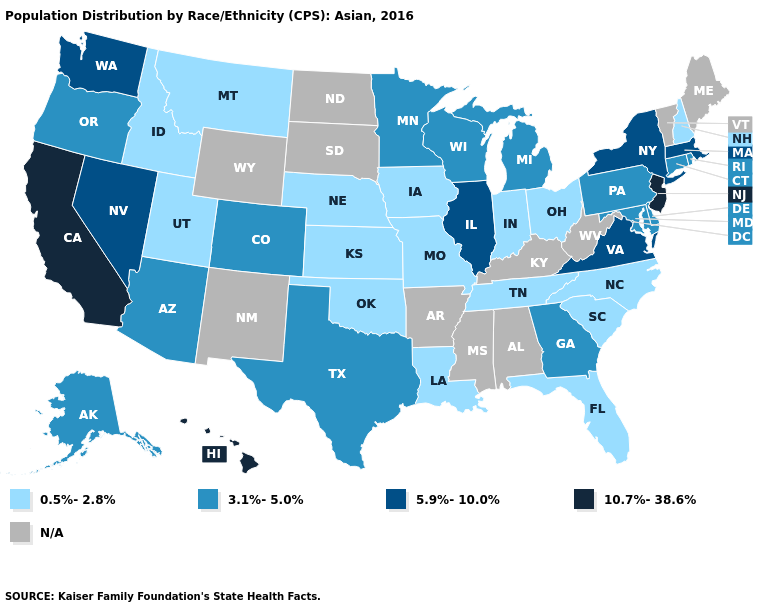What is the highest value in the USA?
Answer briefly. 10.7%-38.6%. What is the value of Nevada?
Concise answer only. 5.9%-10.0%. Which states have the lowest value in the USA?
Quick response, please. Florida, Idaho, Indiana, Iowa, Kansas, Louisiana, Missouri, Montana, Nebraska, New Hampshire, North Carolina, Ohio, Oklahoma, South Carolina, Tennessee, Utah. What is the lowest value in the MidWest?
Write a very short answer. 0.5%-2.8%. What is the value of Missouri?
Answer briefly. 0.5%-2.8%. How many symbols are there in the legend?
Quick response, please. 5. What is the value of Nebraska?
Be succinct. 0.5%-2.8%. Name the states that have a value in the range 0.5%-2.8%?
Keep it brief. Florida, Idaho, Indiana, Iowa, Kansas, Louisiana, Missouri, Montana, Nebraska, New Hampshire, North Carolina, Ohio, Oklahoma, South Carolina, Tennessee, Utah. Name the states that have a value in the range 3.1%-5.0%?
Keep it brief. Alaska, Arizona, Colorado, Connecticut, Delaware, Georgia, Maryland, Michigan, Minnesota, Oregon, Pennsylvania, Rhode Island, Texas, Wisconsin. What is the value of North Dakota?
Be succinct. N/A. Among the states that border Kentucky , which have the highest value?
Give a very brief answer. Illinois, Virginia. Name the states that have a value in the range 5.9%-10.0%?
Give a very brief answer. Illinois, Massachusetts, Nevada, New York, Virginia, Washington. What is the value of Arkansas?
Give a very brief answer. N/A. 